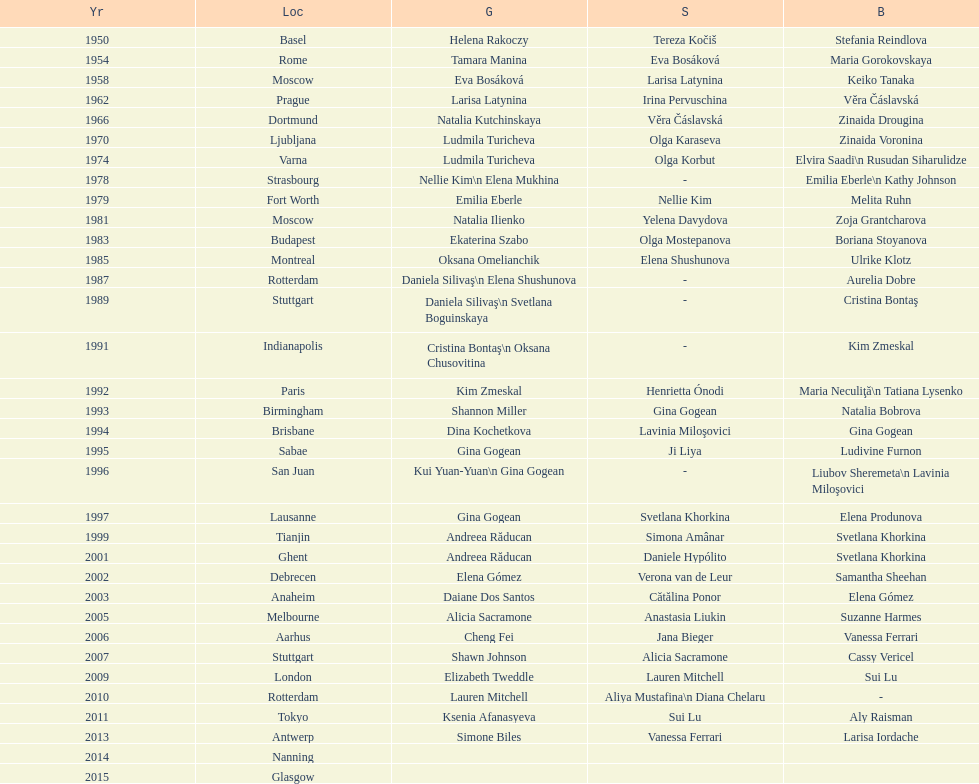How many times was the world artistic gymnastics championships held in the united states? 3. 